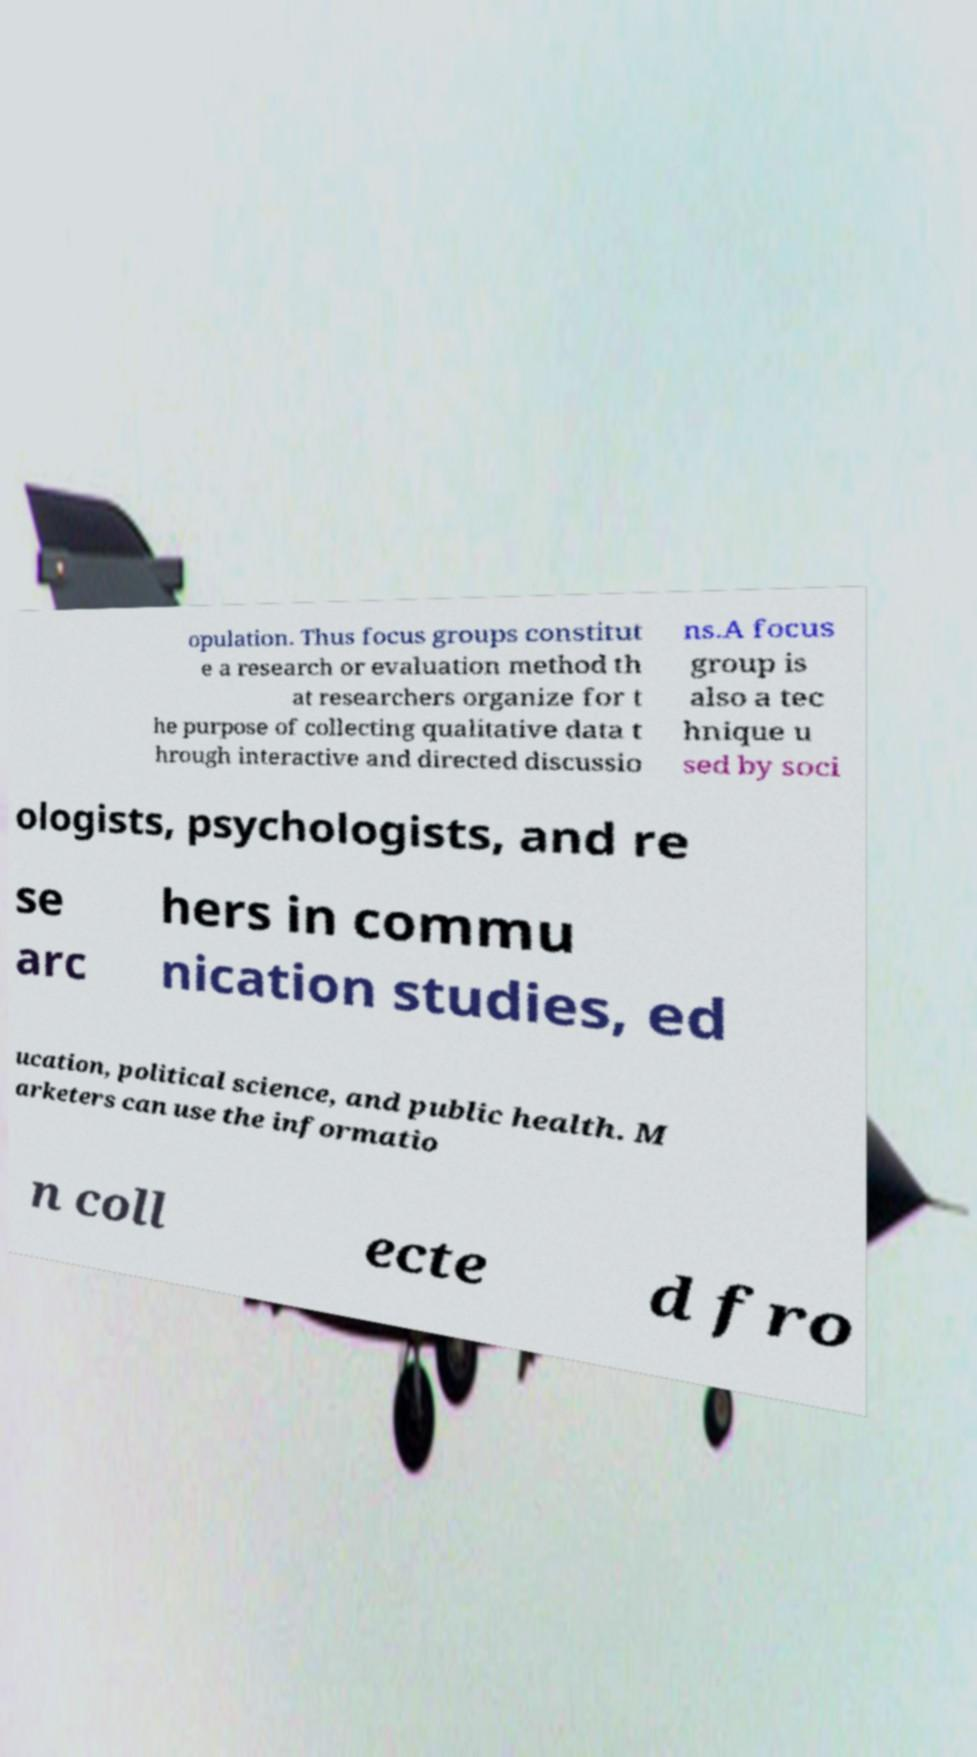Could you assist in decoding the text presented in this image and type it out clearly? opulation. Thus focus groups constitut e a research or evaluation method th at researchers organize for t he purpose of collecting qualitative data t hrough interactive and directed discussio ns.A focus group is also a tec hnique u sed by soci ologists, psychologists, and re se arc hers in commu nication studies, ed ucation, political science, and public health. M arketers can use the informatio n coll ecte d fro 